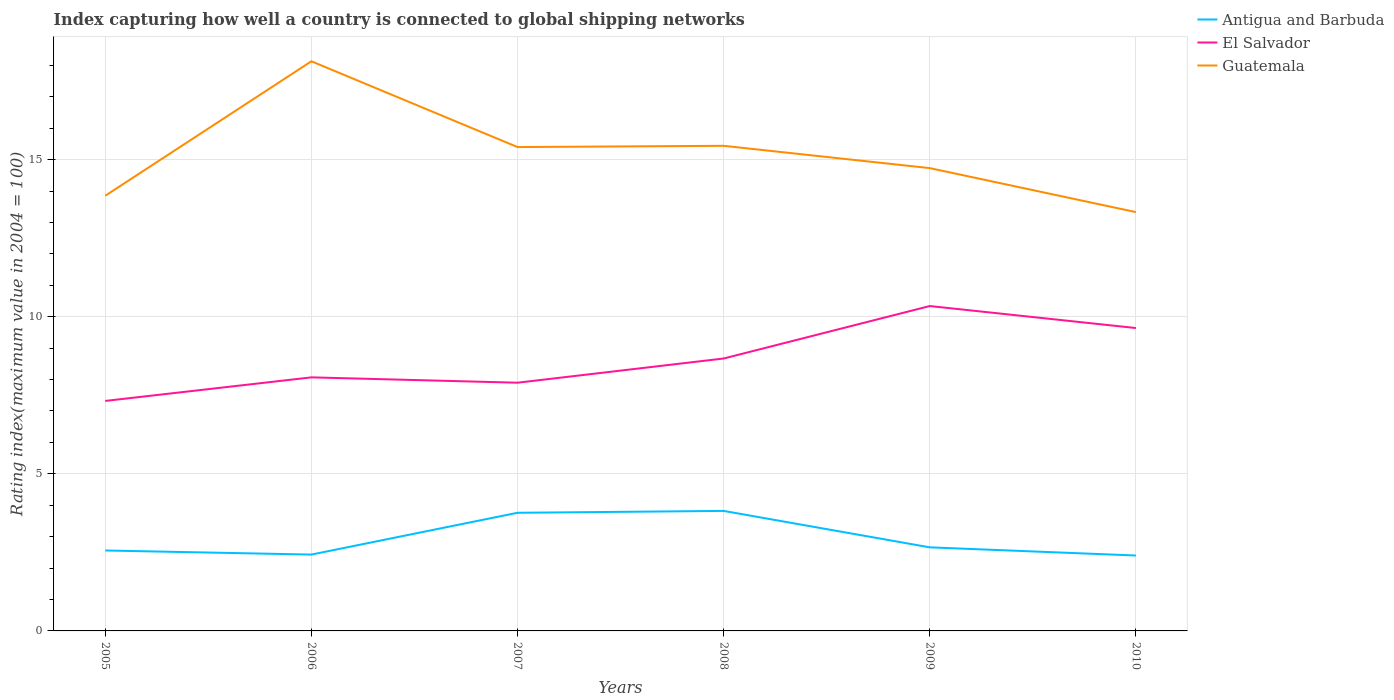How many different coloured lines are there?
Give a very brief answer. 3. Across all years, what is the maximum rating index in El Salvador?
Your answer should be very brief. 7.32. In which year was the rating index in El Salvador maximum?
Your answer should be compact. 2005. What is the total rating index in Antigua and Barbuda in the graph?
Your answer should be compact. 1.1. What is the difference between the highest and the second highest rating index in Antigua and Barbuda?
Your response must be concise. 1.42. What is the difference between the highest and the lowest rating index in El Salvador?
Your answer should be very brief. 3. How many lines are there?
Provide a succinct answer. 3. Where does the legend appear in the graph?
Ensure brevity in your answer.  Top right. How many legend labels are there?
Your answer should be very brief. 3. How are the legend labels stacked?
Keep it short and to the point. Vertical. What is the title of the graph?
Your answer should be compact. Index capturing how well a country is connected to global shipping networks. Does "Latin America(developing only)" appear as one of the legend labels in the graph?
Your response must be concise. No. What is the label or title of the Y-axis?
Offer a terse response. Rating index(maximum value in 2004 = 100). What is the Rating index(maximum value in 2004 = 100) of Antigua and Barbuda in 2005?
Keep it short and to the point. 2.56. What is the Rating index(maximum value in 2004 = 100) in El Salvador in 2005?
Offer a terse response. 7.32. What is the Rating index(maximum value in 2004 = 100) in Guatemala in 2005?
Your answer should be very brief. 13.85. What is the Rating index(maximum value in 2004 = 100) of Antigua and Barbuda in 2006?
Keep it short and to the point. 2.43. What is the Rating index(maximum value in 2004 = 100) in El Salvador in 2006?
Provide a short and direct response. 8.07. What is the Rating index(maximum value in 2004 = 100) of Guatemala in 2006?
Ensure brevity in your answer.  18.13. What is the Rating index(maximum value in 2004 = 100) of Antigua and Barbuda in 2007?
Give a very brief answer. 3.76. What is the Rating index(maximum value in 2004 = 100) of Guatemala in 2007?
Your response must be concise. 15.4. What is the Rating index(maximum value in 2004 = 100) of Antigua and Barbuda in 2008?
Offer a terse response. 3.82. What is the Rating index(maximum value in 2004 = 100) of El Salvador in 2008?
Provide a short and direct response. 8.67. What is the Rating index(maximum value in 2004 = 100) of Guatemala in 2008?
Your answer should be compact. 15.44. What is the Rating index(maximum value in 2004 = 100) in Antigua and Barbuda in 2009?
Offer a very short reply. 2.66. What is the Rating index(maximum value in 2004 = 100) of El Salvador in 2009?
Ensure brevity in your answer.  10.34. What is the Rating index(maximum value in 2004 = 100) in Guatemala in 2009?
Offer a terse response. 14.73. What is the Rating index(maximum value in 2004 = 100) in El Salvador in 2010?
Ensure brevity in your answer.  9.64. What is the Rating index(maximum value in 2004 = 100) of Guatemala in 2010?
Your answer should be very brief. 13.33. Across all years, what is the maximum Rating index(maximum value in 2004 = 100) in Antigua and Barbuda?
Make the answer very short. 3.82. Across all years, what is the maximum Rating index(maximum value in 2004 = 100) of El Salvador?
Give a very brief answer. 10.34. Across all years, what is the maximum Rating index(maximum value in 2004 = 100) of Guatemala?
Provide a succinct answer. 18.13. Across all years, what is the minimum Rating index(maximum value in 2004 = 100) in El Salvador?
Offer a very short reply. 7.32. Across all years, what is the minimum Rating index(maximum value in 2004 = 100) of Guatemala?
Provide a short and direct response. 13.33. What is the total Rating index(maximum value in 2004 = 100) in Antigua and Barbuda in the graph?
Provide a succinct answer. 17.63. What is the total Rating index(maximum value in 2004 = 100) in El Salvador in the graph?
Offer a very short reply. 51.94. What is the total Rating index(maximum value in 2004 = 100) of Guatemala in the graph?
Your answer should be very brief. 90.88. What is the difference between the Rating index(maximum value in 2004 = 100) in Antigua and Barbuda in 2005 and that in 2006?
Keep it short and to the point. 0.13. What is the difference between the Rating index(maximum value in 2004 = 100) in El Salvador in 2005 and that in 2006?
Your answer should be very brief. -0.75. What is the difference between the Rating index(maximum value in 2004 = 100) in Guatemala in 2005 and that in 2006?
Keep it short and to the point. -4.28. What is the difference between the Rating index(maximum value in 2004 = 100) of El Salvador in 2005 and that in 2007?
Your answer should be very brief. -0.58. What is the difference between the Rating index(maximum value in 2004 = 100) of Guatemala in 2005 and that in 2007?
Give a very brief answer. -1.55. What is the difference between the Rating index(maximum value in 2004 = 100) in Antigua and Barbuda in 2005 and that in 2008?
Offer a terse response. -1.26. What is the difference between the Rating index(maximum value in 2004 = 100) in El Salvador in 2005 and that in 2008?
Give a very brief answer. -1.35. What is the difference between the Rating index(maximum value in 2004 = 100) in Guatemala in 2005 and that in 2008?
Offer a terse response. -1.59. What is the difference between the Rating index(maximum value in 2004 = 100) in Antigua and Barbuda in 2005 and that in 2009?
Keep it short and to the point. -0.1. What is the difference between the Rating index(maximum value in 2004 = 100) of El Salvador in 2005 and that in 2009?
Provide a short and direct response. -3.02. What is the difference between the Rating index(maximum value in 2004 = 100) in Guatemala in 2005 and that in 2009?
Offer a very short reply. -0.88. What is the difference between the Rating index(maximum value in 2004 = 100) of Antigua and Barbuda in 2005 and that in 2010?
Your answer should be very brief. 0.16. What is the difference between the Rating index(maximum value in 2004 = 100) in El Salvador in 2005 and that in 2010?
Ensure brevity in your answer.  -2.32. What is the difference between the Rating index(maximum value in 2004 = 100) of Guatemala in 2005 and that in 2010?
Provide a short and direct response. 0.52. What is the difference between the Rating index(maximum value in 2004 = 100) of Antigua and Barbuda in 2006 and that in 2007?
Offer a very short reply. -1.33. What is the difference between the Rating index(maximum value in 2004 = 100) in El Salvador in 2006 and that in 2007?
Give a very brief answer. 0.17. What is the difference between the Rating index(maximum value in 2004 = 100) in Guatemala in 2006 and that in 2007?
Your response must be concise. 2.73. What is the difference between the Rating index(maximum value in 2004 = 100) in Antigua and Barbuda in 2006 and that in 2008?
Your answer should be very brief. -1.39. What is the difference between the Rating index(maximum value in 2004 = 100) of El Salvador in 2006 and that in 2008?
Provide a succinct answer. -0.6. What is the difference between the Rating index(maximum value in 2004 = 100) of Guatemala in 2006 and that in 2008?
Give a very brief answer. 2.69. What is the difference between the Rating index(maximum value in 2004 = 100) in Antigua and Barbuda in 2006 and that in 2009?
Keep it short and to the point. -0.23. What is the difference between the Rating index(maximum value in 2004 = 100) in El Salvador in 2006 and that in 2009?
Ensure brevity in your answer.  -2.27. What is the difference between the Rating index(maximum value in 2004 = 100) in Guatemala in 2006 and that in 2009?
Make the answer very short. 3.4. What is the difference between the Rating index(maximum value in 2004 = 100) in Antigua and Barbuda in 2006 and that in 2010?
Provide a succinct answer. 0.03. What is the difference between the Rating index(maximum value in 2004 = 100) of El Salvador in 2006 and that in 2010?
Give a very brief answer. -1.57. What is the difference between the Rating index(maximum value in 2004 = 100) of Antigua and Barbuda in 2007 and that in 2008?
Give a very brief answer. -0.06. What is the difference between the Rating index(maximum value in 2004 = 100) in El Salvador in 2007 and that in 2008?
Give a very brief answer. -0.77. What is the difference between the Rating index(maximum value in 2004 = 100) of Guatemala in 2007 and that in 2008?
Make the answer very short. -0.04. What is the difference between the Rating index(maximum value in 2004 = 100) of Antigua and Barbuda in 2007 and that in 2009?
Ensure brevity in your answer.  1.1. What is the difference between the Rating index(maximum value in 2004 = 100) of El Salvador in 2007 and that in 2009?
Your response must be concise. -2.44. What is the difference between the Rating index(maximum value in 2004 = 100) in Guatemala in 2007 and that in 2009?
Make the answer very short. 0.67. What is the difference between the Rating index(maximum value in 2004 = 100) in Antigua and Barbuda in 2007 and that in 2010?
Ensure brevity in your answer.  1.36. What is the difference between the Rating index(maximum value in 2004 = 100) of El Salvador in 2007 and that in 2010?
Provide a succinct answer. -1.74. What is the difference between the Rating index(maximum value in 2004 = 100) of Guatemala in 2007 and that in 2010?
Give a very brief answer. 2.07. What is the difference between the Rating index(maximum value in 2004 = 100) in Antigua and Barbuda in 2008 and that in 2009?
Keep it short and to the point. 1.16. What is the difference between the Rating index(maximum value in 2004 = 100) in El Salvador in 2008 and that in 2009?
Provide a succinct answer. -1.67. What is the difference between the Rating index(maximum value in 2004 = 100) of Guatemala in 2008 and that in 2009?
Your response must be concise. 0.71. What is the difference between the Rating index(maximum value in 2004 = 100) of Antigua and Barbuda in 2008 and that in 2010?
Make the answer very short. 1.42. What is the difference between the Rating index(maximum value in 2004 = 100) of El Salvador in 2008 and that in 2010?
Your answer should be compact. -0.97. What is the difference between the Rating index(maximum value in 2004 = 100) in Guatemala in 2008 and that in 2010?
Provide a succinct answer. 2.11. What is the difference between the Rating index(maximum value in 2004 = 100) of Antigua and Barbuda in 2009 and that in 2010?
Your response must be concise. 0.26. What is the difference between the Rating index(maximum value in 2004 = 100) of Antigua and Barbuda in 2005 and the Rating index(maximum value in 2004 = 100) of El Salvador in 2006?
Make the answer very short. -5.51. What is the difference between the Rating index(maximum value in 2004 = 100) of Antigua and Barbuda in 2005 and the Rating index(maximum value in 2004 = 100) of Guatemala in 2006?
Offer a very short reply. -15.57. What is the difference between the Rating index(maximum value in 2004 = 100) of El Salvador in 2005 and the Rating index(maximum value in 2004 = 100) of Guatemala in 2006?
Your response must be concise. -10.81. What is the difference between the Rating index(maximum value in 2004 = 100) of Antigua and Barbuda in 2005 and the Rating index(maximum value in 2004 = 100) of El Salvador in 2007?
Provide a succinct answer. -5.34. What is the difference between the Rating index(maximum value in 2004 = 100) of Antigua and Barbuda in 2005 and the Rating index(maximum value in 2004 = 100) of Guatemala in 2007?
Your answer should be compact. -12.84. What is the difference between the Rating index(maximum value in 2004 = 100) of El Salvador in 2005 and the Rating index(maximum value in 2004 = 100) of Guatemala in 2007?
Make the answer very short. -8.08. What is the difference between the Rating index(maximum value in 2004 = 100) in Antigua and Barbuda in 2005 and the Rating index(maximum value in 2004 = 100) in El Salvador in 2008?
Offer a very short reply. -6.11. What is the difference between the Rating index(maximum value in 2004 = 100) in Antigua and Barbuda in 2005 and the Rating index(maximum value in 2004 = 100) in Guatemala in 2008?
Your response must be concise. -12.88. What is the difference between the Rating index(maximum value in 2004 = 100) of El Salvador in 2005 and the Rating index(maximum value in 2004 = 100) of Guatemala in 2008?
Keep it short and to the point. -8.12. What is the difference between the Rating index(maximum value in 2004 = 100) of Antigua and Barbuda in 2005 and the Rating index(maximum value in 2004 = 100) of El Salvador in 2009?
Make the answer very short. -7.78. What is the difference between the Rating index(maximum value in 2004 = 100) of Antigua and Barbuda in 2005 and the Rating index(maximum value in 2004 = 100) of Guatemala in 2009?
Your answer should be very brief. -12.17. What is the difference between the Rating index(maximum value in 2004 = 100) of El Salvador in 2005 and the Rating index(maximum value in 2004 = 100) of Guatemala in 2009?
Give a very brief answer. -7.41. What is the difference between the Rating index(maximum value in 2004 = 100) of Antigua and Barbuda in 2005 and the Rating index(maximum value in 2004 = 100) of El Salvador in 2010?
Offer a terse response. -7.08. What is the difference between the Rating index(maximum value in 2004 = 100) of Antigua and Barbuda in 2005 and the Rating index(maximum value in 2004 = 100) of Guatemala in 2010?
Provide a short and direct response. -10.77. What is the difference between the Rating index(maximum value in 2004 = 100) of El Salvador in 2005 and the Rating index(maximum value in 2004 = 100) of Guatemala in 2010?
Provide a succinct answer. -6.01. What is the difference between the Rating index(maximum value in 2004 = 100) in Antigua and Barbuda in 2006 and the Rating index(maximum value in 2004 = 100) in El Salvador in 2007?
Provide a short and direct response. -5.47. What is the difference between the Rating index(maximum value in 2004 = 100) in Antigua and Barbuda in 2006 and the Rating index(maximum value in 2004 = 100) in Guatemala in 2007?
Offer a terse response. -12.97. What is the difference between the Rating index(maximum value in 2004 = 100) in El Salvador in 2006 and the Rating index(maximum value in 2004 = 100) in Guatemala in 2007?
Keep it short and to the point. -7.33. What is the difference between the Rating index(maximum value in 2004 = 100) of Antigua and Barbuda in 2006 and the Rating index(maximum value in 2004 = 100) of El Salvador in 2008?
Your answer should be compact. -6.24. What is the difference between the Rating index(maximum value in 2004 = 100) of Antigua and Barbuda in 2006 and the Rating index(maximum value in 2004 = 100) of Guatemala in 2008?
Ensure brevity in your answer.  -13.01. What is the difference between the Rating index(maximum value in 2004 = 100) in El Salvador in 2006 and the Rating index(maximum value in 2004 = 100) in Guatemala in 2008?
Your answer should be very brief. -7.37. What is the difference between the Rating index(maximum value in 2004 = 100) of Antigua and Barbuda in 2006 and the Rating index(maximum value in 2004 = 100) of El Salvador in 2009?
Offer a terse response. -7.91. What is the difference between the Rating index(maximum value in 2004 = 100) in Antigua and Barbuda in 2006 and the Rating index(maximum value in 2004 = 100) in Guatemala in 2009?
Make the answer very short. -12.3. What is the difference between the Rating index(maximum value in 2004 = 100) of El Salvador in 2006 and the Rating index(maximum value in 2004 = 100) of Guatemala in 2009?
Your answer should be compact. -6.66. What is the difference between the Rating index(maximum value in 2004 = 100) of Antigua and Barbuda in 2006 and the Rating index(maximum value in 2004 = 100) of El Salvador in 2010?
Your response must be concise. -7.21. What is the difference between the Rating index(maximum value in 2004 = 100) in Antigua and Barbuda in 2006 and the Rating index(maximum value in 2004 = 100) in Guatemala in 2010?
Offer a very short reply. -10.9. What is the difference between the Rating index(maximum value in 2004 = 100) in El Salvador in 2006 and the Rating index(maximum value in 2004 = 100) in Guatemala in 2010?
Provide a short and direct response. -5.26. What is the difference between the Rating index(maximum value in 2004 = 100) in Antigua and Barbuda in 2007 and the Rating index(maximum value in 2004 = 100) in El Salvador in 2008?
Provide a short and direct response. -4.91. What is the difference between the Rating index(maximum value in 2004 = 100) of Antigua and Barbuda in 2007 and the Rating index(maximum value in 2004 = 100) of Guatemala in 2008?
Keep it short and to the point. -11.68. What is the difference between the Rating index(maximum value in 2004 = 100) of El Salvador in 2007 and the Rating index(maximum value in 2004 = 100) of Guatemala in 2008?
Ensure brevity in your answer.  -7.54. What is the difference between the Rating index(maximum value in 2004 = 100) in Antigua and Barbuda in 2007 and the Rating index(maximum value in 2004 = 100) in El Salvador in 2009?
Keep it short and to the point. -6.58. What is the difference between the Rating index(maximum value in 2004 = 100) of Antigua and Barbuda in 2007 and the Rating index(maximum value in 2004 = 100) of Guatemala in 2009?
Your answer should be compact. -10.97. What is the difference between the Rating index(maximum value in 2004 = 100) in El Salvador in 2007 and the Rating index(maximum value in 2004 = 100) in Guatemala in 2009?
Offer a terse response. -6.83. What is the difference between the Rating index(maximum value in 2004 = 100) of Antigua and Barbuda in 2007 and the Rating index(maximum value in 2004 = 100) of El Salvador in 2010?
Your answer should be compact. -5.88. What is the difference between the Rating index(maximum value in 2004 = 100) of Antigua and Barbuda in 2007 and the Rating index(maximum value in 2004 = 100) of Guatemala in 2010?
Provide a succinct answer. -9.57. What is the difference between the Rating index(maximum value in 2004 = 100) in El Salvador in 2007 and the Rating index(maximum value in 2004 = 100) in Guatemala in 2010?
Ensure brevity in your answer.  -5.43. What is the difference between the Rating index(maximum value in 2004 = 100) of Antigua and Barbuda in 2008 and the Rating index(maximum value in 2004 = 100) of El Salvador in 2009?
Your answer should be very brief. -6.52. What is the difference between the Rating index(maximum value in 2004 = 100) in Antigua and Barbuda in 2008 and the Rating index(maximum value in 2004 = 100) in Guatemala in 2009?
Your answer should be very brief. -10.91. What is the difference between the Rating index(maximum value in 2004 = 100) of El Salvador in 2008 and the Rating index(maximum value in 2004 = 100) of Guatemala in 2009?
Offer a very short reply. -6.06. What is the difference between the Rating index(maximum value in 2004 = 100) of Antigua and Barbuda in 2008 and the Rating index(maximum value in 2004 = 100) of El Salvador in 2010?
Keep it short and to the point. -5.82. What is the difference between the Rating index(maximum value in 2004 = 100) in Antigua and Barbuda in 2008 and the Rating index(maximum value in 2004 = 100) in Guatemala in 2010?
Provide a succinct answer. -9.51. What is the difference between the Rating index(maximum value in 2004 = 100) of El Salvador in 2008 and the Rating index(maximum value in 2004 = 100) of Guatemala in 2010?
Your response must be concise. -4.66. What is the difference between the Rating index(maximum value in 2004 = 100) of Antigua and Barbuda in 2009 and the Rating index(maximum value in 2004 = 100) of El Salvador in 2010?
Give a very brief answer. -6.98. What is the difference between the Rating index(maximum value in 2004 = 100) in Antigua and Barbuda in 2009 and the Rating index(maximum value in 2004 = 100) in Guatemala in 2010?
Make the answer very short. -10.67. What is the difference between the Rating index(maximum value in 2004 = 100) of El Salvador in 2009 and the Rating index(maximum value in 2004 = 100) of Guatemala in 2010?
Keep it short and to the point. -2.99. What is the average Rating index(maximum value in 2004 = 100) in Antigua and Barbuda per year?
Keep it short and to the point. 2.94. What is the average Rating index(maximum value in 2004 = 100) in El Salvador per year?
Give a very brief answer. 8.66. What is the average Rating index(maximum value in 2004 = 100) of Guatemala per year?
Make the answer very short. 15.15. In the year 2005, what is the difference between the Rating index(maximum value in 2004 = 100) in Antigua and Barbuda and Rating index(maximum value in 2004 = 100) in El Salvador?
Give a very brief answer. -4.76. In the year 2005, what is the difference between the Rating index(maximum value in 2004 = 100) in Antigua and Barbuda and Rating index(maximum value in 2004 = 100) in Guatemala?
Your answer should be very brief. -11.29. In the year 2005, what is the difference between the Rating index(maximum value in 2004 = 100) of El Salvador and Rating index(maximum value in 2004 = 100) of Guatemala?
Offer a terse response. -6.53. In the year 2006, what is the difference between the Rating index(maximum value in 2004 = 100) in Antigua and Barbuda and Rating index(maximum value in 2004 = 100) in El Salvador?
Ensure brevity in your answer.  -5.64. In the year 2006, what is the difference between the Rating index(maximum value in 2004 = 100) in Antigua and Barbuda and Rating index(maximum value in 2004 = 100) in Guatemala?
Make the answer very short. -15.7. In the year 2006, what is the difference between the Rating index(maximum value in 2004 = 100) in El Salvador and Rating index(maximum value in 2004 = 100) in Guatemala?
Keep it short and to the point. -10.06. In the year 2007, what is the difference between the Rating index(maximum value in 2004 = 100) of Antigua and Barbuda and Rating index(maximum value in 2004 = 100) of El Salvador?
Provide a short and direct response. -4.14. In the year 2007, what is the difference between the Rating index(maximum value in 2004 = 100) in Antigua and Barbuda and Rating index(maximum value in 2004 = 100) in Guatemala?
Provide a short and direct response. -11.64. In the year 2008, what is the difference between the Rating index(maximum value in 2004 = 100) of Antigua and Barbuda and Rating index(maximum value in 2004 = 100) of El Salvador?
Keep it short and to the point. -4.85. In the year 2008, what is the difference between the Rating index(maximum value in 2004 = 100) of Antigua and Barbuda and Rating index(maximum value in 2004 = 100) of Guatemala?
Provide a succinct answer. -11.62. In the year 2008, what is the difference between the Rating index(maximum value in 2004 = 100) in El Salvador and Rating index(maximum value in 2004 = 100) in Guatemala?
Provide a short and direct response. -6.77. In the year 2009, what is the difference between the Rating index(maximum value in 2004 = 100) of Antigua and Barbuda and Rating index(maximum value in 2004 = 100) of El Salvador?
Your answer should be very brief. -7.68. In the year 2009, what is the difference between the Rating index(maximum value in 2004 = 100) of Antigua and Barbuda and Rating index(maximum value in 2004 = 100) of Guatemala?
Offer a terse response. -12.07. In the year 2009, what is the difference between the Rating index(maximum value in 2004 = 100) in El Salvador and Rating index(maximum value in 2004 = 100) in Guatemala?
Ensure brevity in your answer.  -4.39. In the year 2010, what is the difference between the Rating index(maximum value in 2004 = 100) in Antigua and Barbuda and Rating index(maximum value in 2004 = 100) in El Salvador?
Offer a very short reply. -7.24. In the year 2010, what is the difference between the Rating index(maximum value in 2004 = 100) in Antigua and Barbuda and Rating index(maximum value in 2004 = 100) in Guatemala?
Offer a very short reply. -10.93. In the year 2010, what is the difference between the Rating index(maximum value in 2004 = 100) in El Salvador and Rating index(maximum value in 2004 = 100) in Guatemala?
Your answer should be compact. -3.69. What is the ratio of the Rating index(maximum value in 2004 = 100) in Antigua and Barbuda in 2005 to that in 2006?
Your answer should be very brief. 1.05. What is the ratio of the Rating index(maximum value in 2004 = 100) in El Salvador in 2005 to that in 2006?
Your answer should be compact. 0.91. What is the ratio of the Rating index(maximum value in 2004 = 100) in Guatemala in 2005 to that in 2006?
Give a very brief answer. 0.76. What is the ratio of the Rating index(maximum value in 2004 = 100) of Antigua and Barbuda in 2005 to that in 2007?
Your response must be concise. 0.68. What is the ratio of the Rating index(maximum value in 2004 = 100) of El Salvador in 2005 to that in 2007?
Ensure brevity in your answer.  0.93. What is the ratio of the Rating index(maximum value in 2004 = 100) of Guatemala in 2005 to that in 2007?
Ensure brevity in your answer.  0.9. What is the ratio of the Rating index(maximum value in 2004 = 100) in Antigua and Barbuda in 2005 to that in 2008?
Your response must be concise. 0.67. What is the ratio of the Rating index(maximum value in 2004 = 100) of El Salvador in 2005 to that in 2008?
Your response must be concise. 0.84. What is the ratio of the Rating index(maximum value in 2004 = 100) in Guatemala in 2005 to that in 2008?
Your answer should be compact. 0.9. What is the ratio of the Rating index(maximum value in 2004 = 100) in Antigua and Barbuda in 2005 to that in 2009?
Keep it short and to the point. 0.96. What is the ratio of the Rating index(maximum value in 2004 = 100) in El Salvador in 2005 to that in 2009?
Provide a succinct answer. 0.71. What is the ratio of the Rating index(maximum value in 2004 = 100) in Guatemala in 2005 to that in 2009?
Keep it short and to the point. 0.94. What is the ratio of the Rating index(maximum value in 2004 = 100) of Antigua and Barbuda in 2005 to that in 2010?
Your response must be concise. 1.07. What is the ratio of the Rating index(maximum value in 2004 = 100) in El Salvador in 2005 to that in 2010?
Give a very brief answer. 0.76. What is the ratio of the Rating index(maximum value in 2004 = 100) of Guatemala in 2005 to that in 2010?
Provide a short and direct response. 1.04. What is the ratio of the Rating index(maximum value in 2004 = 100) in Antigua and Barbuda in 2006 to that in 2007?
Provide a short and direct response. 0.65. What is the ratio of the Rating index(maximum value in 2004 = 100) in El Salvador in 2006 to that in 2007?
Your answer should be compact. 1.02. What is the ratio of the Rating index(maximum value in 2004 = 100) of Guatemala in 2006 to that in 2007?
Offer a very short reply. 1.18. What is the ratio of the Rating index(maximum value in 2004 = 100) of Antigua and Barbuda in 2006 to that in 2008?
Offer a terse response. 0.64. What is the ratio of the Rating index(maximum value in 2004 = 100) of El Salvador in 2006 to that in 2008?
Your answer should be very brief. 0.93. What is the ratio of the Rating index(maximum value in 2004 = 100) of Guatemala in 2006 to that in 2008?
Provide a succinct answer. 1.17. What is the ratio of the Rating index(maximum value in 2004 = 100) of Antigua and Barbuda in 2006 to that in 2009?
Give a very brief answer. 0.91. What is the ratio of the Rating index(maximum value in 2004 = 100) in El Salvador in 2006 to that in 2009?
Give a very brief answer. 0.78. What is the ratio of the Rating index(maximum value in 2004 = 100) of Guatemala in 2006 to that in 2009?
Your response must be concise. 1.23. What is the ratio of the Rating index(maximum value in 2004 = 100) in Antigua and Barbuda in 2006 to that in 2010?
Keep it short and to the point. 1.01. What is the ratio of the Rating index(maximum value in 2004 = 100) in El Salvador in 2006 to that in 2010?
Provide a succinct answer. 0.84. What is the ratio of the Rating index(maximum value in 2004 = 100) in Guatemala in 2006 to that in 2010?
Give a very brief answer. 1.36. What is the ratio of the Rating index(maximum value in 2004 = 100) in Antigua and Barbuda in 2007 to that in 2008?
Provide a succinct answer. 0.98. What is the ratio of the Rating index(maximum value in 2004 = 100) of El Salvador in 2007 to that in 2008?
Offer a very short reply. 0.91. What is the ratio of the Rating index(maximum value in 2004 = 100) in Antigua and Barbuda in 2007 to that in 2009?
Make the answer very short. 1.41. What is the ratio of the Rating index(maximum value in 2004 = 100) of El Salvador in 2007 to that in 2009?
Your response must be concise. 0.76. What is the ratio of the Rating index(maximum value in 2004 = 100) in Guatemala in 2007 to that in 2009?
Ensure brevity in your answer.  1.05. What is the ratio of the Rating index(maximum value in 2004 = 100) of Antigua and Barbuda in 2007 to that in 2010?
Make the answer very short. 1.57. What is the ratio of the Rating index(maximum value in 2004 = 100) in El Salvador in 2007 to that in 2010?
Your response must be concise. 0.82. What is the ratio of the Rating index(maximum value in 2004 = 100) in Guatemala in 2007 to that in 2010?
Keep it short and to the point. 1.16. What is the ratio of the Rating index(maximum value in 2004 = 100) of Antigua and Barbuda in 2008 to that in 2009?
Offer a terse response. 1.44. What is the ratio of the Rating index(maximum value in 2004 = 100) of El Salvador in 2008 to that in 2009?
Your answer should be compact. 0.84. What is the ratio of the Rating index(maximum value in 2004 = 100) in Guatemala in 2008 to that in 2009?
Your response must be concise. 1.05. What is the ratio of the Rating index(maximum value in 2004 = 100) of Antigua and Barbuda in 2008 to that in 2010?
Make the answer very short. 1.59. What is the ratio of the Rating index(maximum value in 2004 = 100) of El Salvador in 2008 to that in 2010?
Provide a short and direct response. 0.9. What is the ratio of the Rating index(maximum value in 2004 = 100) in Guatemala in 2008 to that in 2010?
Make the answer very short. 1.16. What is the ratio of the Rating index(maximum value in 2004 = 100) of Antigua and Barbuda in 2009 to that in 2010?
Provide a succinct answer. 1.11. What is the ratio of the Rating index(maximum value in 2004 = 100) in El Salvador in 2009 to that in 2010?
Provide a short and direct response. 1.07. What is the ratio of the Rating index(maximum value in 2004 = 100) of Guatemala in 2009 to that in 2010?
Provide a short and direct response. 1.1. What is the difference between the highest and the second highest Rating index(maximum value in 2004 = 100) in El Salvador?
Ensure brevity in your answer.  0.7. What is the difference between the highest and the second highest Rating index(maximum value in 2004 = 100) in Guatemala?
Your answer should be compact. 2.69. What is the difference between the highest and the lowest Rating index(maximum value in 2004 = 100) of Antigua and Barbuda?
Give a very brief answer. 1.42. What is the difference between the highest and the lowest Rating index(maximum value in 2004 = 100) in El Salvador?
Ensure brevity in your answer.  3.02. What is the difference between the highest and the lowest Rating index(maximum value in 2004 = 100) in Guatemala?
Give a very brief answer. 4.8. 